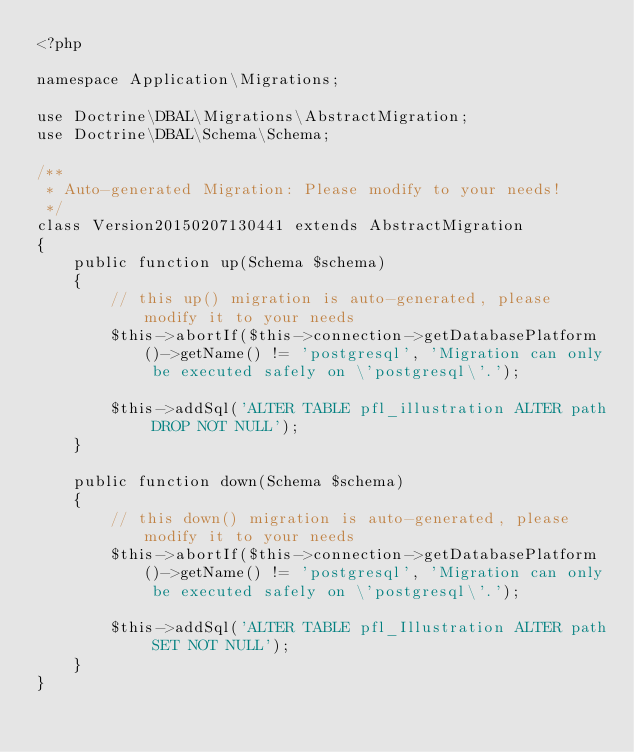Convert code to text. <code><loc_0><loc_0><loc_500><loc_500><_PHP_><?php

namespace Application\Migrations;

use Doctrine\DBAL\Migrations\AbstractMigration;
use Doctrine\DBAL\Schema\Schema;

/**
 * Auto-generated Migration: Please modify to your needs!
 */
class Version20150207130441 extends AbstractMigration
{
    public function up(Schema $schema)
    {
        // this up() migration is auto-generated, please modify it to your needs
        $this->abortIf($this->connection->getDatabasePlatform()->getName() != 'postgresql', 'Migration can only be executed safely on \'postgresql\'.');

        $this->addSql('ALTER TABLE pfl_illustration ALTER path DROP NOT NULL');
    }

    public function down(Schema $schema)
    {
        // this down() migration is auto-generated, please modify it to your needs
        $this->abortIf($this->connection->getDatabasePlatform()->getName() != 'postgresql', 'Migration can only be executed safely on \'postgresql\'.');

        $this->addSql('ALTER TABLE pfl_Illustration ALTER path SET NOT NULL');
    }
}
</code> 